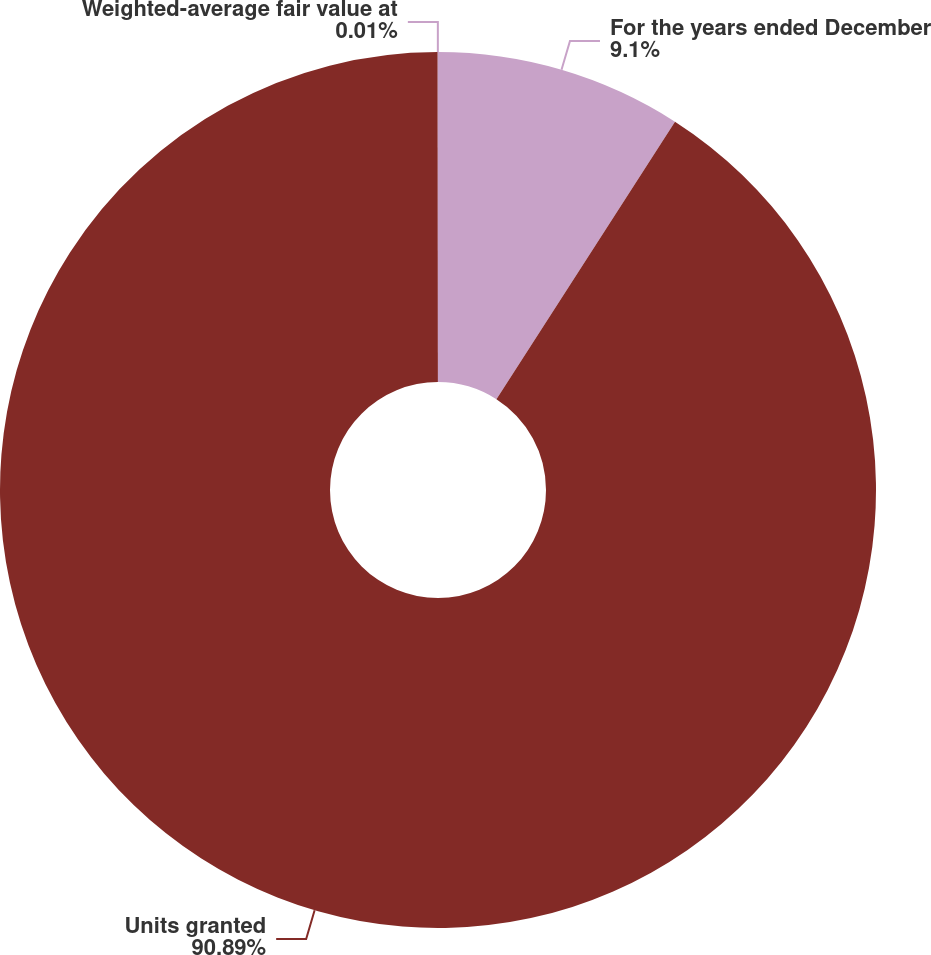<chart> <loc_0><loc_0><loc_500><loc_500><pie_chart><fcel>For the years ended December<fcel>Units granted<fcel>Weighted-average fair value at<nl><fcel>9.1%<fcel>90.89%<fcel>0.01%<nl></chart> 